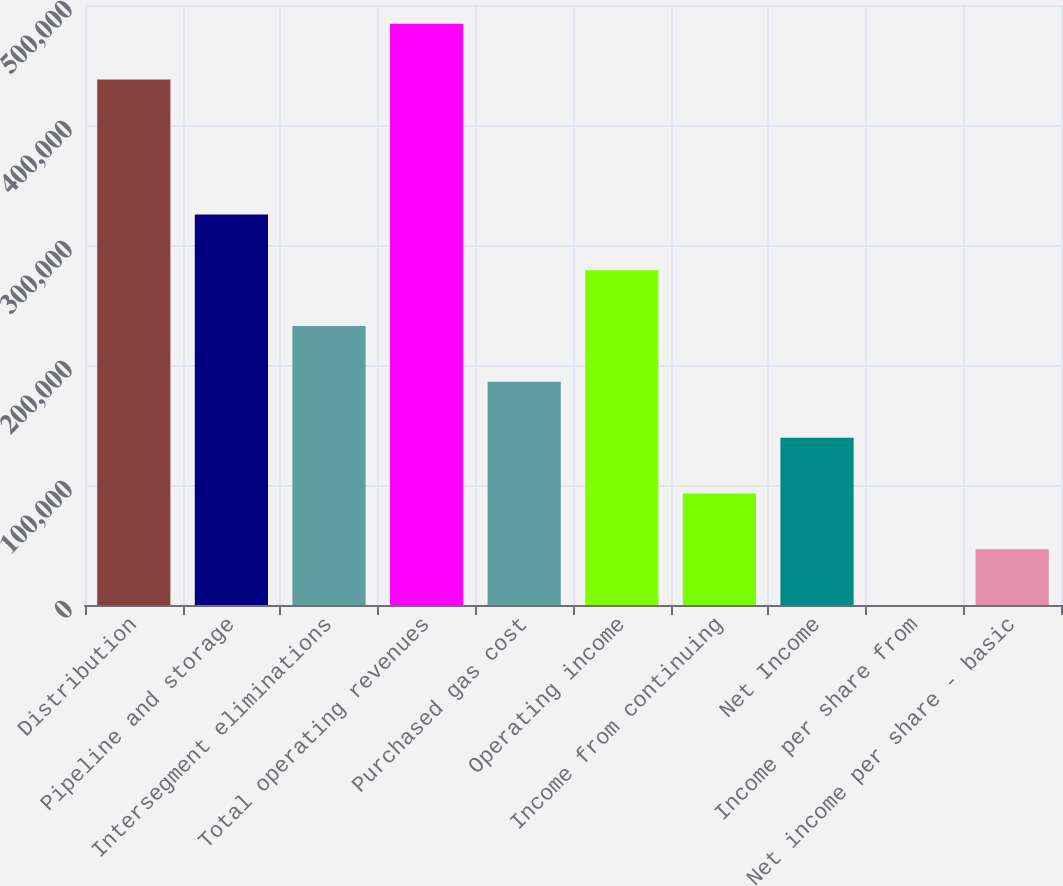<chart> <loc_0><loc_0><loc_500><loc_500><bar_chart><fcel>Distribution<fcel>Pipeline and storage<fcel>Intersegment eliminations<fcel>Total operating revenues<fcel>Purchased gas cost<fcel>Operating income<fcel>Income from continuing<fcel>Net Income<fcel>Income per share from<fcel>Net income per share - basic<nl><fcel>437918<fcel>325416<fcel>232440<fcel>484406<fcel>185952<fcel>278928<fcel>92976.3<fcel>139464<fcel>0.34<fcel>46488.3<nl></chart> 